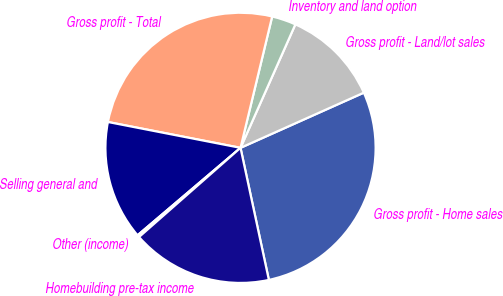Convert chart to OTSL. <chart><loc_0><loc_0><loc_500><loc_500><pie_chart><fcel>Gross profit - Home sales<fcel>Gross profit - Land/lot sales<fcel>Inventory and land option<fcel>Gross profit - Total<fcel>Selling general and<fcel>Other (income)<fcel>Homebuilding pre-tax income<nl><fcel>28.33%<fcel>11.65%<fcel>2.89%<fcel>25.7%<fcel>14.27%<fcel>0.27%<fcel>16.89%<nl></chart> 